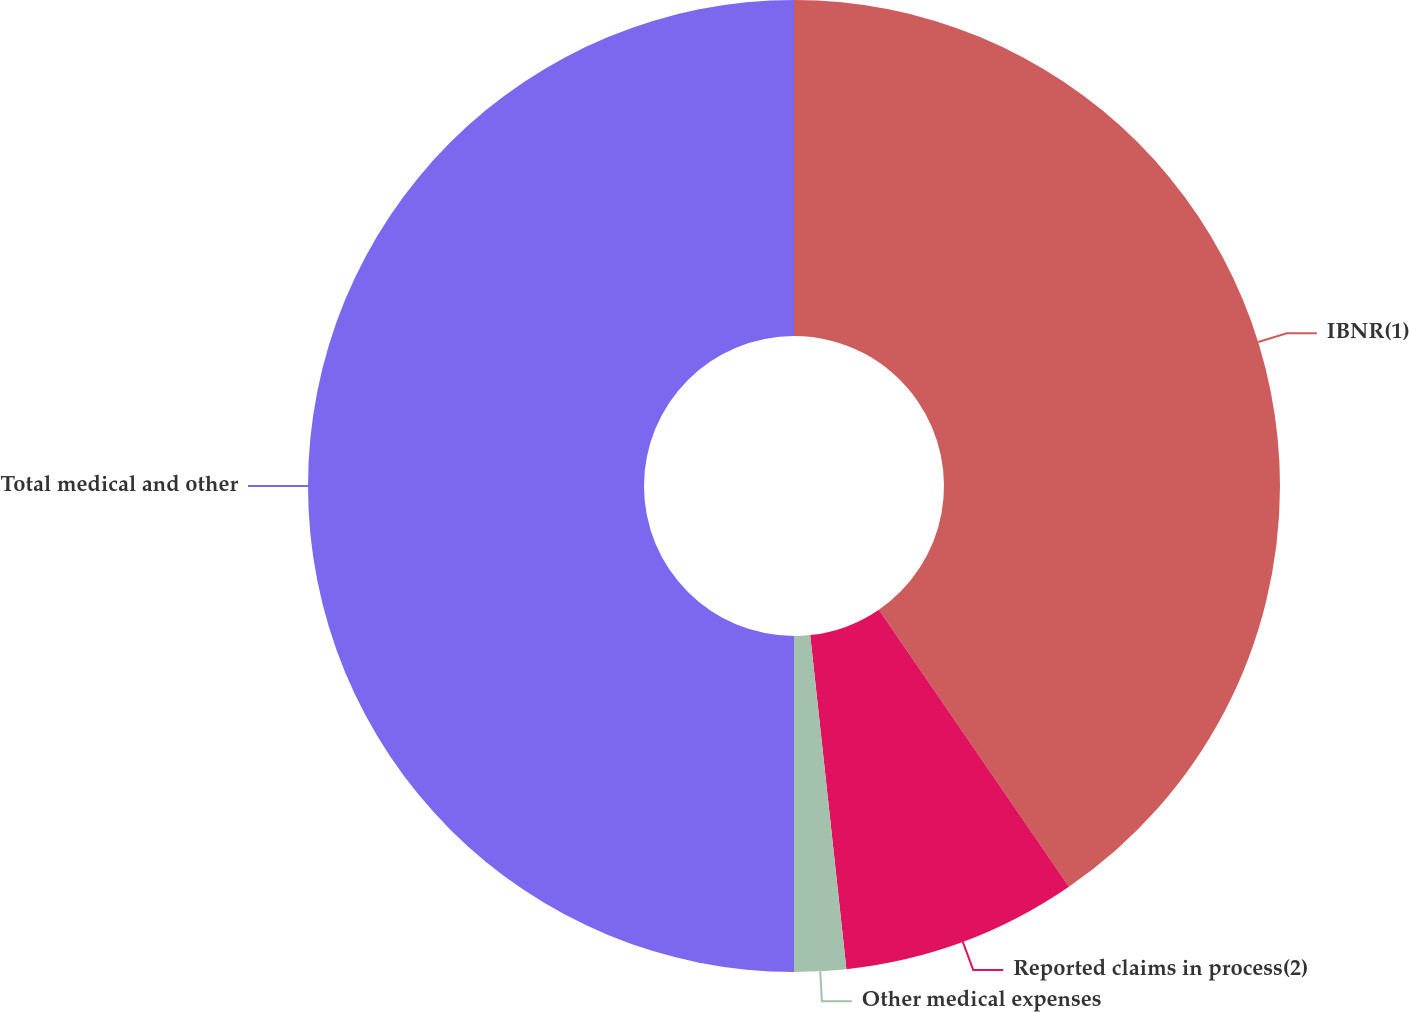<chart> <loc_0><loc_0><loc_500><loc_500><pie_chart><fcel>IBNR(1)<fcel>Reported claims in process(2)<fcel>Other medical expenses<fcel>Total medical and other<nl><fcel>40.43%<fcel>7.85%<fcel>1.72%<fcel>50.0%<nl></chart> 